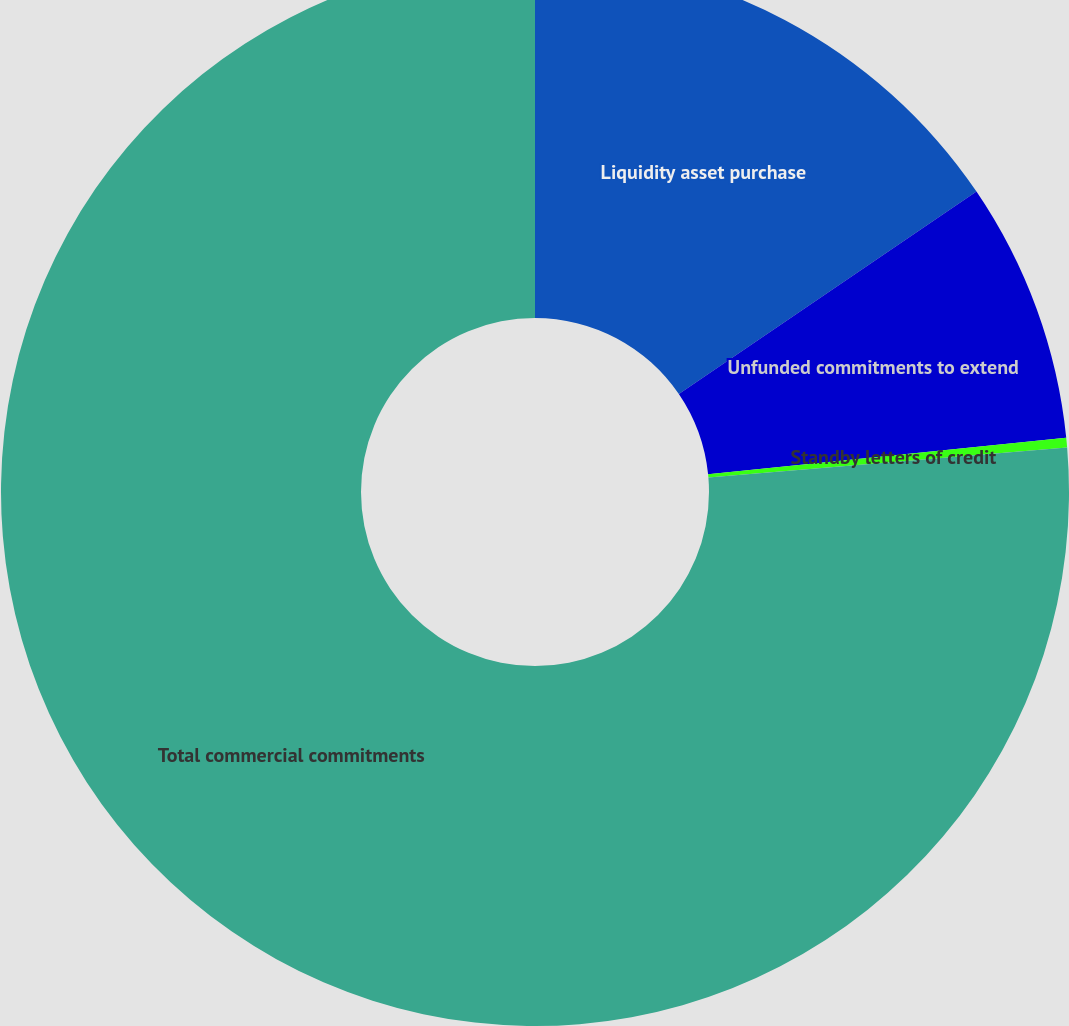<chart> <loc_0><loc_0><loc_500><loc_500><pie_chart><fcel>Liquidity asset purchase<fcel>Unfunded commitments to extend<fcel>Standby letters of credit<fcel>Total commercial commitments<nl><fcel>15.49%<fcel>7.89%<fcel>0.29%<fcel>76.33%<nl></chart> 